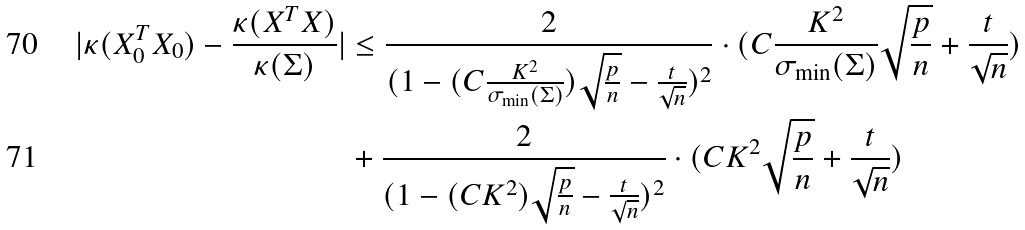Convert formula to latex. <formula><loc_0><loc_0><loc_500><loc_500>| \kappa ( X _ { 0 } ^ { T } X _ { 0 } ) - \frac { \kappa ( X ^ { T } X ) } { \kappa ( \Sigma ) } | & \leq \frac { 2 } { ( 1 - ( C \frac { K ^ { 2 } } { \sigma _ { \min } ( \Sigma ) } ) \sqrt { \frac { p } { n } } - \frac { t } { \sqrt { n } } ) ^ { 2 } } \cdot ( C \frac { K ^ { 2 } } { \sigma _ { \min } ( \Sigma ) } \sqrt { \frac { p } { n } } + \frac { t } { \sqrt { n } } ) \\ & + \frac { 2 } { ( 1 - ( C K ^ { 2 } ) \sqrt { \frac { p } { n } } - \frac { t } { \sqrt { n } } ) ^ { 2 } } \cdot ( C K ^ { 2 } \sqrt { \frac { p } { n } } + \frac { t } { \sqrt { n } } )</formula> 